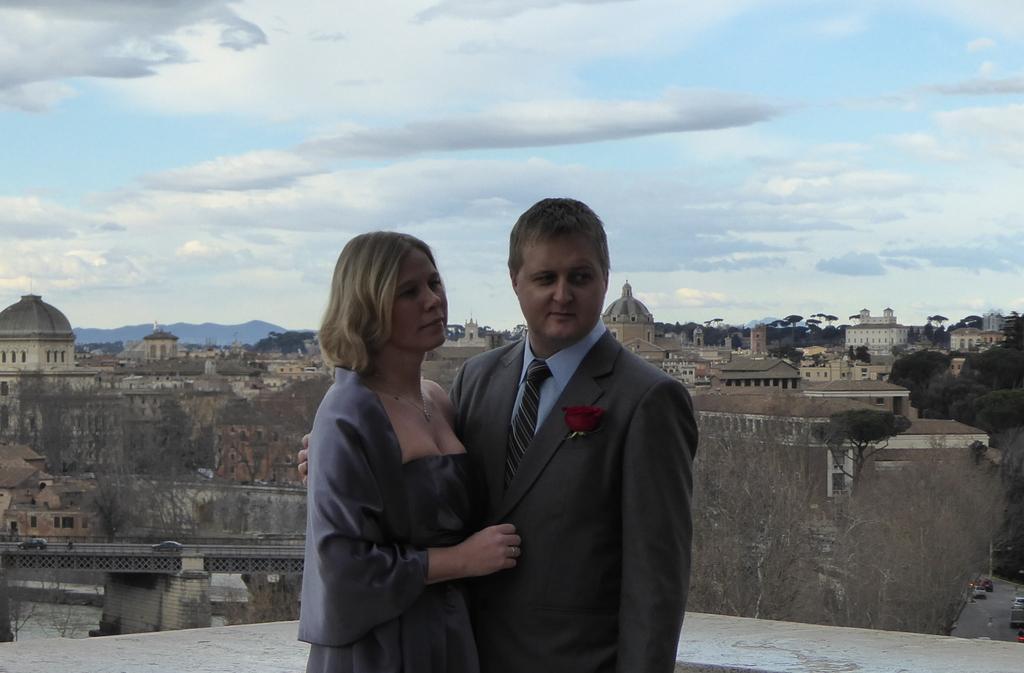Could you give a brief overview of what you see in this image? In this picture, we can see two persons, a few buildings, bridgewater, trees, hills and the sky with clouds. 